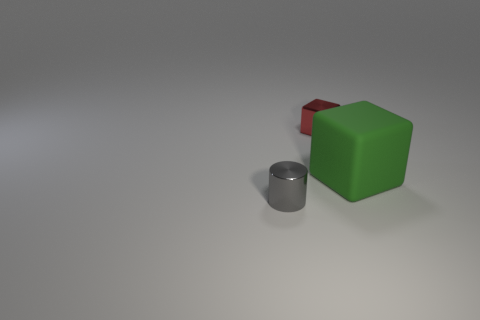Add 2 large green rubber things. How many objects exist? 5 Subtract all blocks. How many objects are left? 1 Subtract all large objects. Subtract all tiny red things. How many objects are left? 1 Add 1 tiny cylinders. How many tiny cylinders are left? 2 Add 2 brown metallic objects. How many brown metallic objects exist? 2 Subtract 0 green cylinders. How many objects are left? 3 